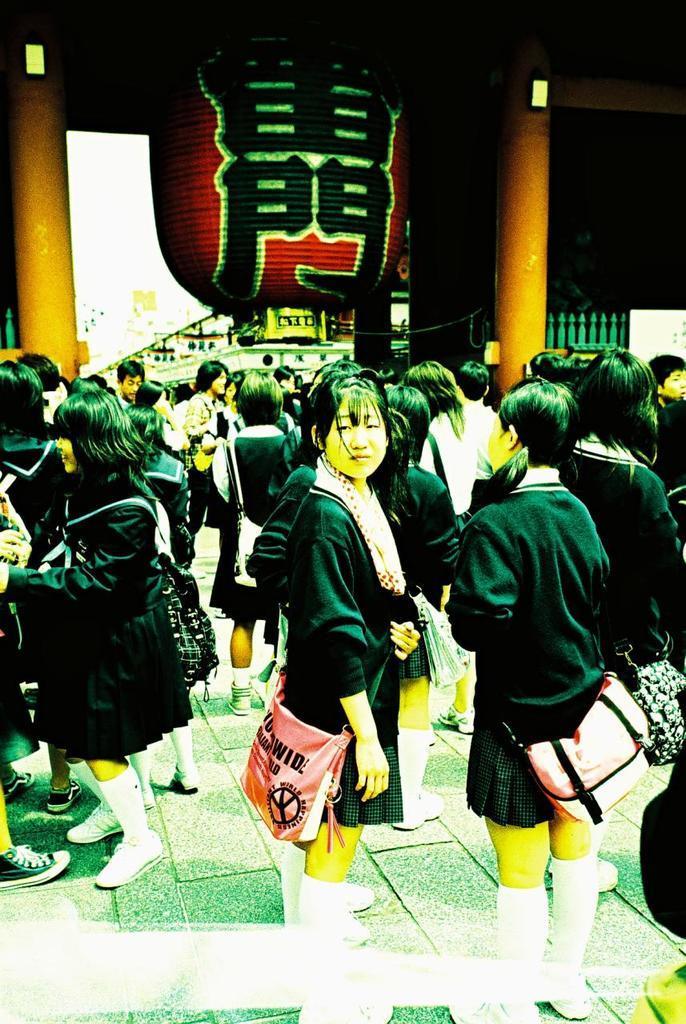In one or two sentences, can you explain what this image depicts? In this image we can see a group of people standing and wearing the bags, there are some pillars, grille and some other objects. 